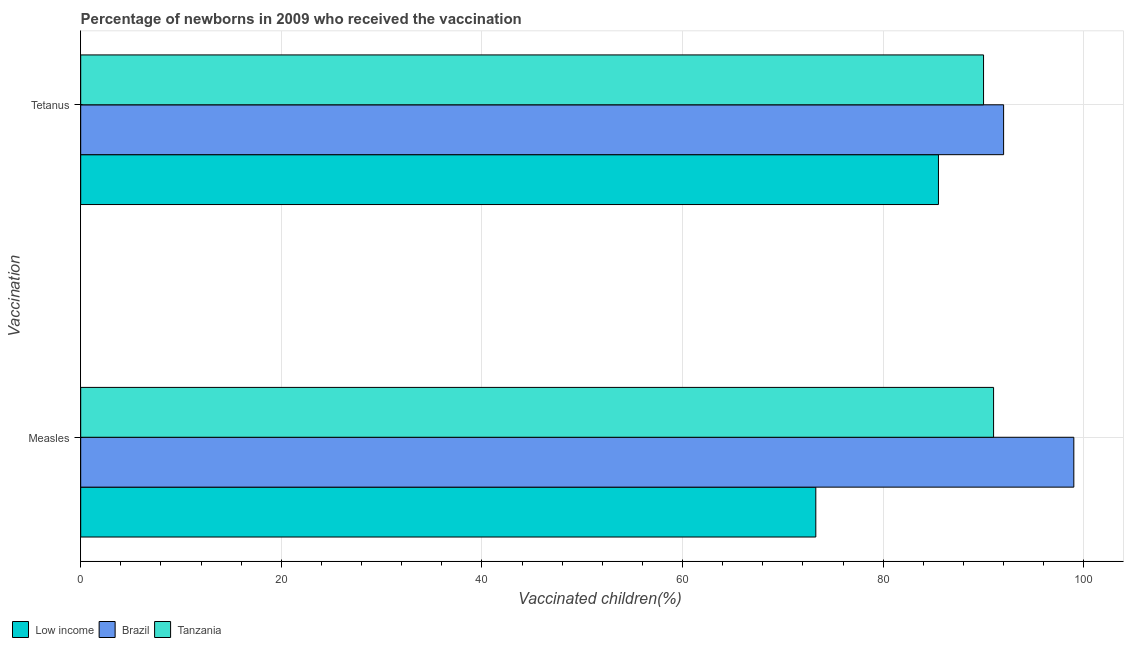How many groups of bars are there?
Make the answer very short. 2. What is the label of the 1st group of bars from the top?
Make the answer very short. Tetanus. What is the percentage of newborns who received vaccination for tetanus in Low income?
Your answer should be compact. 85.51. Across all countries, what is the maximum percentage of newborns who received vaccination for measles?
Your answer should be very brief. 99. Across all countries, what is the minimum percentage of newborns who received vaccination for measles?
Your answer should be very brief. 73.28. What is the total percentage of newborns who received vaccination for measles in the graph?
Ensure brevity in your answer.  263.28. What is the difference between the percentage of newborns who received vaccination for measles in Tanzania and that in Low income?
Keep it short and to the point. 17.72. What is the difference between the percentage of newborns who received vaccination for tetanus in Brazil and the percentage of newborns who received vaccination for measles in Low income?
Your response must be concise. 18.72. What is the average percentage of newborns who received vaccination for tetanus per country?
Ensure brevity in your answer.  89.17. What is the difference between the percentage of newborns who received vaccination for tetanus and percentage of newborns who received vaccination for measles in Tanzania?
Provide a short and direct response. -1. In how many countries, is the percentage of newborns who received vaccination for measles greater than 4 %?
Provide a short and direct response. 3. What is the ratio of the percentage of newborns who received vaccination for tetanus in Brazil to that in Tanzania?
Your answer should be compact. 1.02. Is the percentage of newborns who received vaccination for measles in Tanzania less than that in Low income?
Ensure brevity in your answer.  No. How many bars are there?
Your answer should be compact. 6. Are all the bars in the graph horizontal?
Make the answer very short. Yes. How many countries are there in the graph?
Provide a succinct answer. 3. What is the difference between two consecutive major ticks on the X-axis?
Offer a terse response. 20. Are the values on the major ticks of X-axis written in scientific E-notation?
Give a very brief answer. No. How are the legend labels stacked?
Your response must be concise. Horizontal. What is the title of the graph?
Your answer should be very brief. Percentage of newborns in 2009 who received the vaccination. Does "Middle East & North Africa (developing only)" appear as one of the legend labels in the graph?
Make the answer very short. No. What is the label or title of the X-axis?
Offer a very short reply. Vaccinated children(%)
. What is the label or title of the Y-axis?
Provide a succinct answer. Vaccination. What is the Vaccinated children(%)
 in Low income in Measles?
Ensure brevity in your answer.  73.28. What is the Vaccinated children(%)
 of Tanzania in Measles?
Provide a succinct answer. 91. What is the Vaccinated children(%)
 of Low income in Tetanus?
Your response must be concise. 85.51. What is the Vaccinated children(%)
 of Brazil in Tetanus?
Provide a short and direct response. 92. What is the Vaccinated children(%)
 in Tanzania in Tetanus?
Your answer should be compact. 90. Across all Vaccination, what is the maximum Vaccinated children(%)
 in Low income?
Provide a short and direct response. 85.51. Across all Vaccination, what is the maximum Vaccinated children(%)
 in Brazil?
Keep it short and to the point. 99. Across all Vaccination, what is the maximum Vaccinated children(%)
 of Tanzania?
Offer a terse response. 91. Across all Vaccination, what is the minimum Vaccinated children(%)
 of Low income?
Give a very brief answer. 73.28. Across all Vaccination, what is the minimum Vaccinated children(%)
 of Brazil?
Offer a very short reply. 92. Across all Vaccination, what is the minimum Vaccinated children(%)
 in Tanzania?
Keep it short and to the point. 90. What is the total Vaccinated children(%)
 in Low income in the graph?
Offer a terse response. 158.78. What is the total Vaccinated children(%)
 in Brazil in the graph?
Make the answer very short. 191. What is the total Vaccinated children(%)
 in Tanzania in the graph?
Your response must be concise. 181. What is the difference between the Vaccinated children(%)
 of Low income in Measles and that in Tetanus?
Your answer should be very brief. -12.23. What is the difference between the Vaccinated children(%)
 of Low income in Measles and the Vaccinated children(%)
 of Brazil in Tetanus?
Offer a terse response. -18.72. What is the difference between the Vaccinated children(%)
 in Low income in Measles and the Vaccinated children(%)
 in Tanzania in Tetanus?
Your answer should be compact. -16.72. What is the average Vaccinated children(%)
 in Low income per Vaccination?
Your response must be concise. 79.39. What is the average Vaccinated children(%)
 in Brazil per Vaccination?
Provide a short and direct response. 95.5. What is the average Vaccinated children(%)
 in Tanzania per Vaccination?
Your response must be concise. 90.5. What is the difference between the Vaccinated children(%)
 in Low income and Vaccinated children(%)
 in Brazil in Measles?
Provide a short and direct response. -25.72. What is the difference between the Vaccinated children(%)
 in Low income and Vaccinated children(%)
 in Tanzania in Measles?
Provide a short and direct response. -17.72. What is the difference between the Vaccinated children(%)
 in Low income and Vaccinated children(%)
 in Brazil in Tetanus?
Offer a terse response. -6.49. What is the difference between the Vaccinated children(%)
 of Low income and Vaccinated children(%)
 of Tanzania in Tetanus?
Give a very brief answer. -4.49. What is the difference between the Vaccinated children(%)
 of Brazil and Vaccinated children(%)
 of Tanzania in Tetanus?
Provide a succinct answer. 2. What is the ratio of the Vaccinated children(%)
 of Low income in Measles to that in Tetanus?
Give a very brief answer. 0.86. What is the ratio of the Vaccinated children(%)
 of Brazil in Measles to that in Tetanus?
Your response must be concise. 1.08. What is the ratio of the Vaccinated children(%)
 in Tanzania in Measles to that in Tetanus?
Provide a succinct answer. 1.01. What is the difference between the highest and the second highest Vaccinated children(%)
 in Low income?
Give a very brief answer. 12.23. What is the difference between the highest and the lowest Vaccinated children(%)
 in Low income?
Give a very brief answer. 12.23. What is the difference between the highest and the lowest Vaccinated children(%)
 of Brazil?
Ensure brevity in your answer.  7. What is the difference between the highest and the lowest Vaccinated children(%)
 of Tanzania?
Give a very brief answer. 1. 